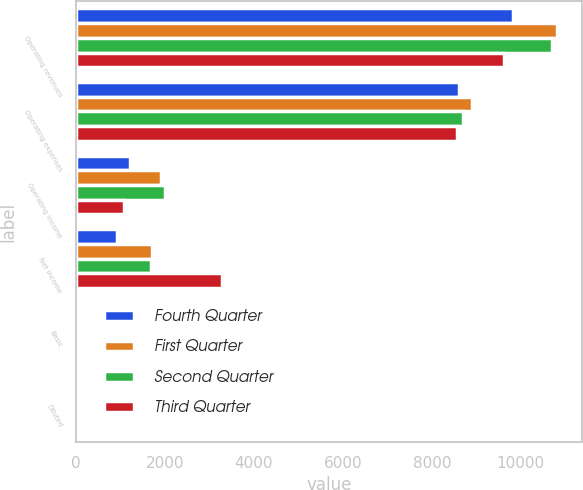Convert chart. <chart><loc_0><loc_0><loc_500><loc_500><stacked_bar_chart><ecel><fcel>Operating revenues<fcel>Operating expenses<fcel>Operating income<fcel>Net income<fcel>Basic<fcel>Diluted<nl><fcel>Fourth Quarter<fcel>9827<fcel>8611<fcel>1216<fcel>932<fcel>1.34<fcel>1.3<nl><fcel>First Quarter<fcel>10827<fcel>8906<fcel>1921<fcel>1704<fcel>2.47<fcel>2.41<nl><fcel>Second Quarter<fcel>10706<fcel>8707<fcel>1999<fcel>1693<fcel>2.56<fcel>2.49<nl><fcel>Third Quarter<fcel>9630<fcel>8562<fcel>1068<fcel>3281<fcel>5.24<fcel>5.09<nl></chart> 